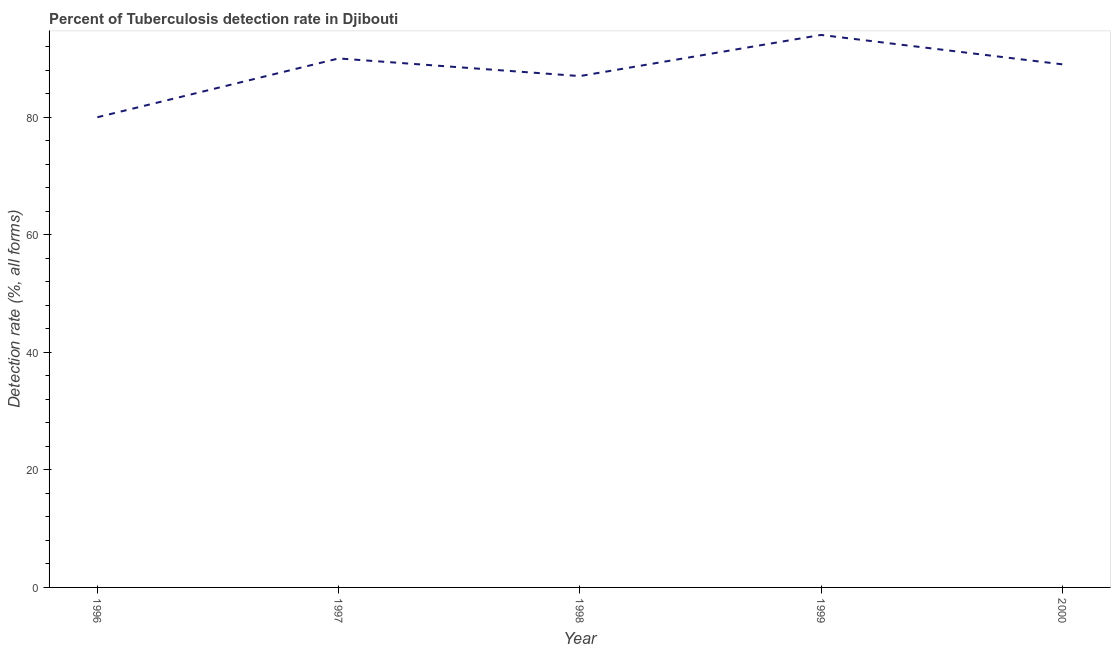What is the detection rate of tuberculosis in 1999?
Ensure brevity in your answer.  94. Across all years, what is the maximum detection rate of tuberculosis?
Make the answer very short. 94. Across all years, what is the minimum detection rate of tuberculosis?
Offer a very short reply. 80. What is the sum of the detection rate of tuberculosis?
Offer a very short reply. 440. What is the difference between the detection rate of tuberculosis in 1999 and 2000?
Make the answer very short. 5. What is the median detection rate of tuberculosis?
Ensure brevity in your answer.  89. In how many years, is the detection rate of tuberculosis greater than 48 %?
Your answer should be very brief. 5. Do a majority of the years between 1998 and 2000 (inclusive) have detection rate of tuberculosis greater than 76 %?
Your answer should be very brief. Yes. What is the ratio of the detection rate of tuberculosis in 1997 to that in 1999?
Offer a terse response. 0.96. Is the sum of the detection rate of tuberculosis in 1996 and 2000 greater than the maximum detection rate of tuberculosis across all years?
Keep it short and to the point. Yes. What is the difference between the highest and the lowest detection rate of tuberculosis?
Your answer should be very brief. 14. In how many years, is the detection rate of tuberculosis greater than the average detection rate of tuberculosis taken over all years?
Your answer should be compact. 3. How many lines are there?
Provide a succinct answer. 1. Are the values on the major ticks of Y-axis written in scientific E-notation?
Your answer should be very brief. No. Does the graph contain any zero values?
Your answer should be compact. No. What is the title of the graph?
Your answer should be compact. Percent of Tuberculosis detection rate in Djibouti. What is the label or title of the Y-axis?
Offer a very short reply. Detection rate (%, all forms). What is the Detection rate (%, all forms) in 1998?
Offer a terse response. 87. What is the Detection rate (%, all forms) of 1999?
Give a very brief answer. 94. What is the Detection rate (%, all forms) of 2000?
Ensure brevity in your answer.  89. What is the difference between the Detection rate (%, all forms) in 1996 and 1999?
Your response must be concise. -14. What is the difference between the Detection rate (%, all forms) in 1997 and 2000?
Offer a very short reply. 1. What is the difference between the Detection rate (%, all forms) in 1999 and 2000?
Offer a terse response. 5. What is the ratio of the Detection rate (%, all forms) in 1996 to that in 1997?
Keep it short and to the point. 0.89. What is the ratio of the Detection rate (%, all forms) in 1996 to that in 1998?
Provide a succinct answer. 0.92. What is the ratio of the Detection rate (%, all forms) in 1996 to that in 1999?
Offer a very short reply. 0.85. What is the ratio of the Detection rate (%, all forms) in 1996 to that in 2000?
Keep it short and to the point. 0.9. What is the ratio of the Detection rate (%, all forms) in 1997 to that in 1998?
Provide a short and direct response. 1.03. What is the ratio of the Detection rate (%, all forms) in 1997 to that in 1999?
Give a very brief answer. 0.96. What is the ratio of the Detection rate (%, all forms) in 1998 to that in 1999?
Provide a succinct answer. 0.93. What is the ratio of the Detection rate (%, all forms) in 1999 to that in 2000?
Make the answer very short. 1.06. 